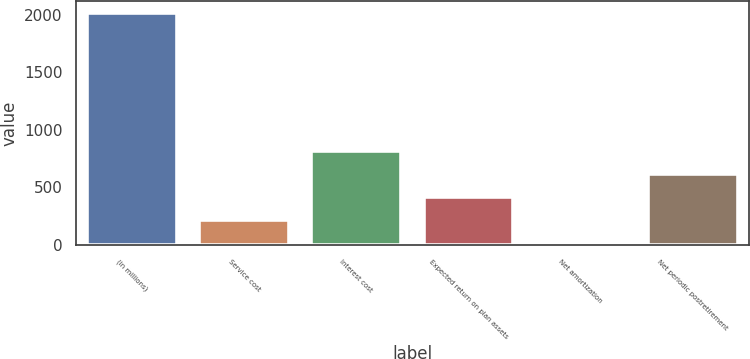Convert chart. <chart><loc_0><loc_0><loc_500><loc_500><bar_chart><fcel>(in millions)<fcel>Service cost<fcel>Interest cost<fcel>Expected return on plan assets<fcel>Net amortization<fcel>Net periodic postretirement<nl><fcel>2015<fcel>220.4<fcel>818.6<fcel>419.8<fcel>21<fcel>619.2<nl></chart> 